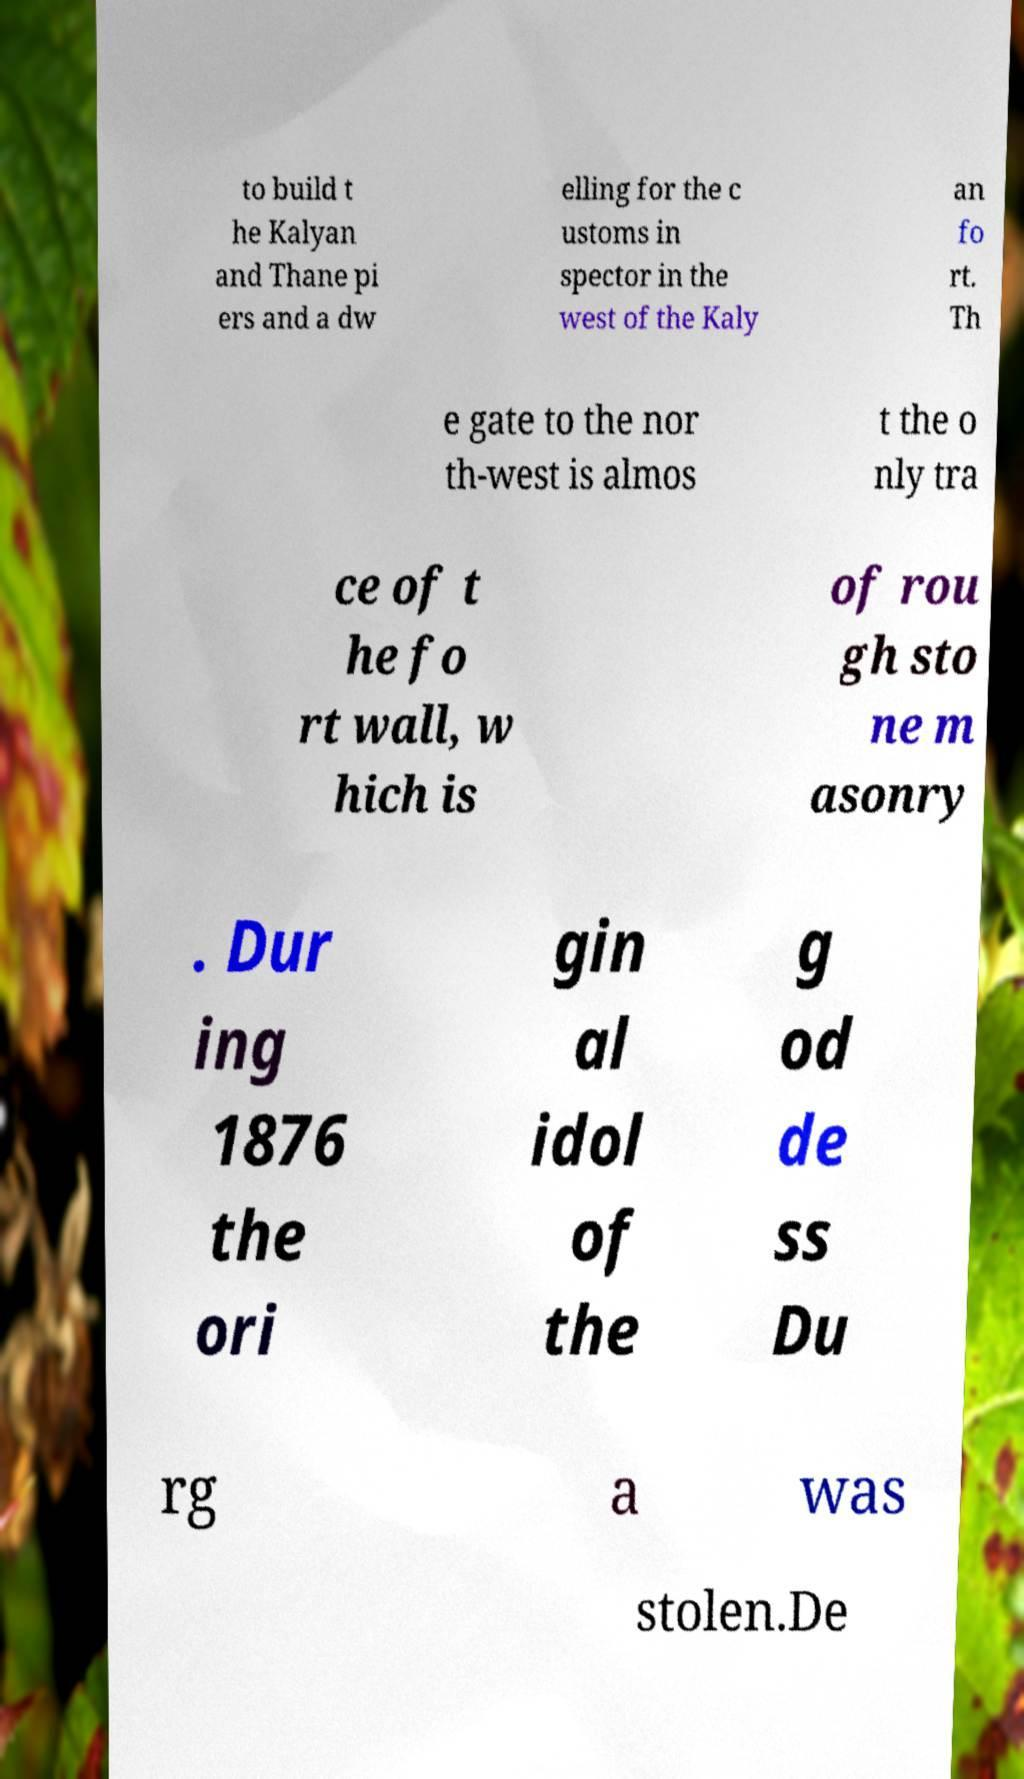Could you assist in decoding the text presented in this image and type it out clearly? to build t he Kalyan and Thane pi ers and a dw elling for the c ustoms in spector in the west of the Kaly an fo rt. Th e gate to the nor th-west is almos t the o nly tra ce of t he fo rt wall, w hich is of rou gh sto ne m asonry . Dur ing 1876 the ori gin al idol of the g od de ss Du rg a was stolen.De 